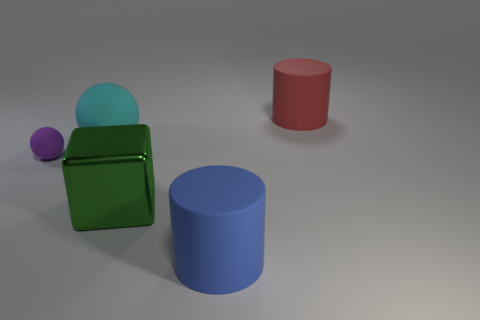There is a matte ball that is on the right side of the tiny rubber thing; is its color the same as the large cube?
Your response must be concise. No. How many red rubber objects are there?
Offer a terse response. 1. Do the large cylinder that is behind the big cyan rubber object and the blue cylinder have the same material?
Provide a succinct answer. Yes. Are there any other things that have the same material as the blue thing?
Your answer should be very brief. Yes. There is a big matte cylinder that is to the right of the blue rubber object that is in front of the red thing; what number of rubber cylinders are behind it?
Your answer should be very brief. 0. The red rubber cylinder is what size?
Give a very brief answer. Large. Do the large rubber ball and the tiny thing have the same color?
Ensure brevity in your answer.  No. What size is the matte cylinder that is behind the cyan rubber ball?
Provide a succinct answer. Large. Do the object to the right of the blue thing and the thing that is in front of the green metallic object have the same color?
Give a very brief answer. No. How many other things are there of the same shape as the large cyan object?
Offer a terse response. 1. 